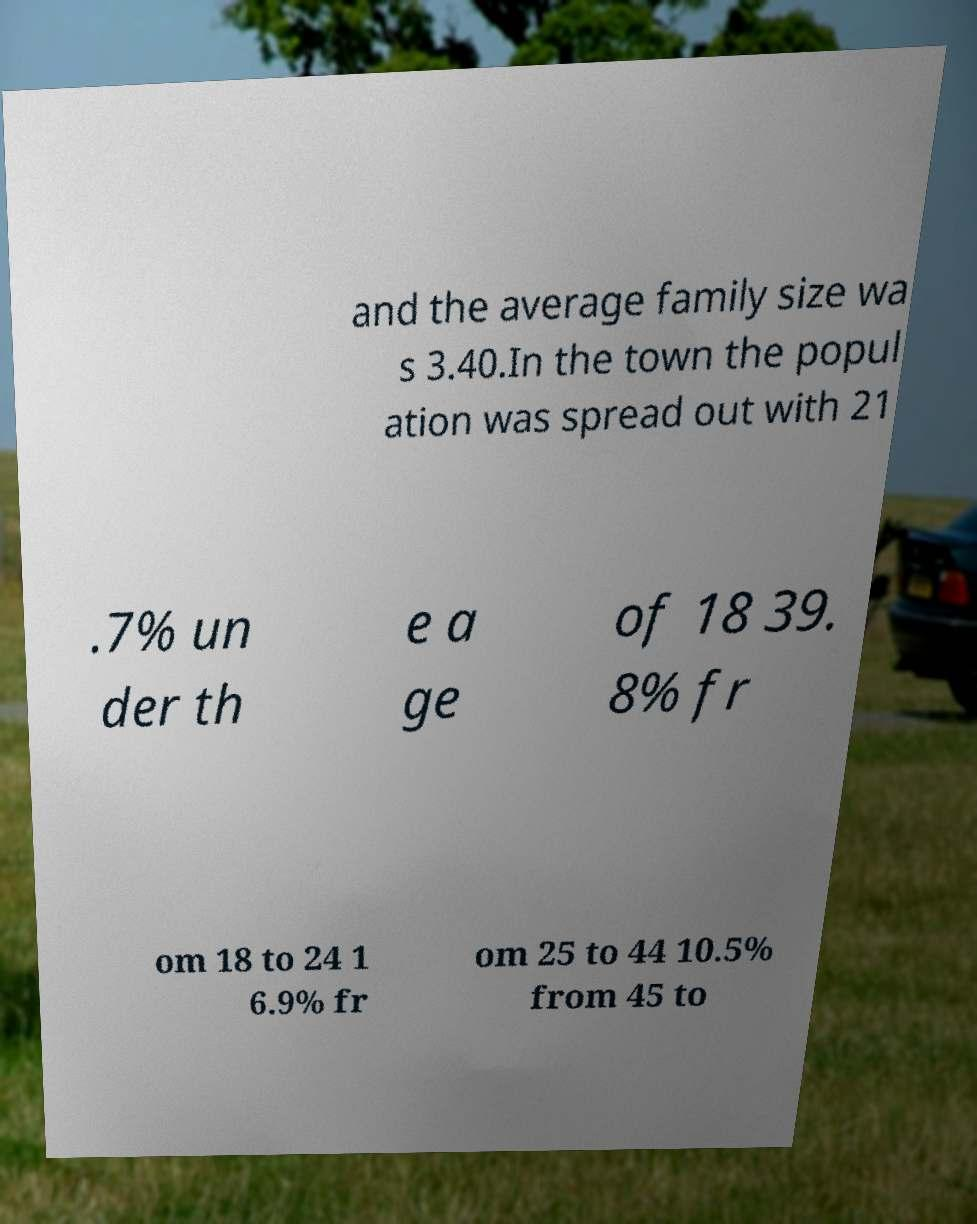Please identify and transcribe the text found in this image. and the average family size wa s 3.40.In the town the popul ation was spread out with 21 .7% un der th e a ge of 18 39. 8% fr om 18 to 24 1 6.9% fr om 25 to 44 10.5% from 45 to 